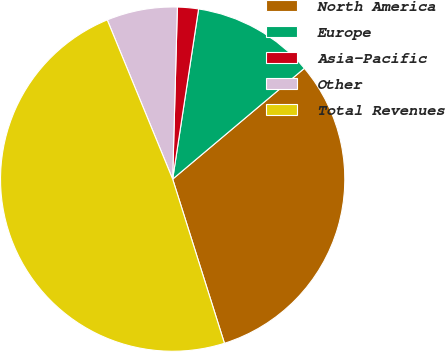Convert chart to OTSL. <chart><loc_0><loc_0><loc_500><loc_500><pie_chart><fcel>North America<fcel>Europe<fcel>Asia-Pacific<fcel>Other<fcel>Total Revenues<nl><fcel>31.27%<fcel>11.46%<fcel>1.97%<fcel>6.64%<fcel>48.66%<nl></chart> 